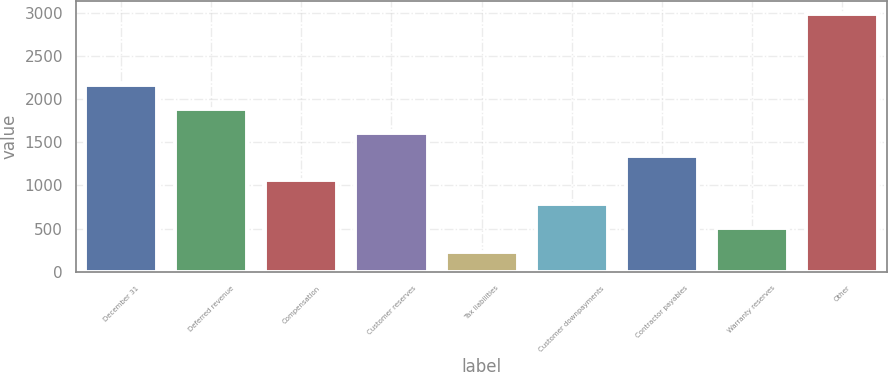<chart> <loc_0><loc_0><loc_500><loc_500><bar_chart><fcel>December 31<fcel>Deferred revenue<fcel>Compensation<fcel>Customer reserves<fcel>Tax liabilities<fcel>Customer downpayments<fcel>Contractor payables<fcel>Warranty reserves<fcel>Other<nl><fcel>2161.8<fcel>1886.4<fcel>1060.2<fcel>1611<fcel>234<fcel>784.8<fcel>1335.6<fcel>509.4<fcel>2988<nl></chart> 